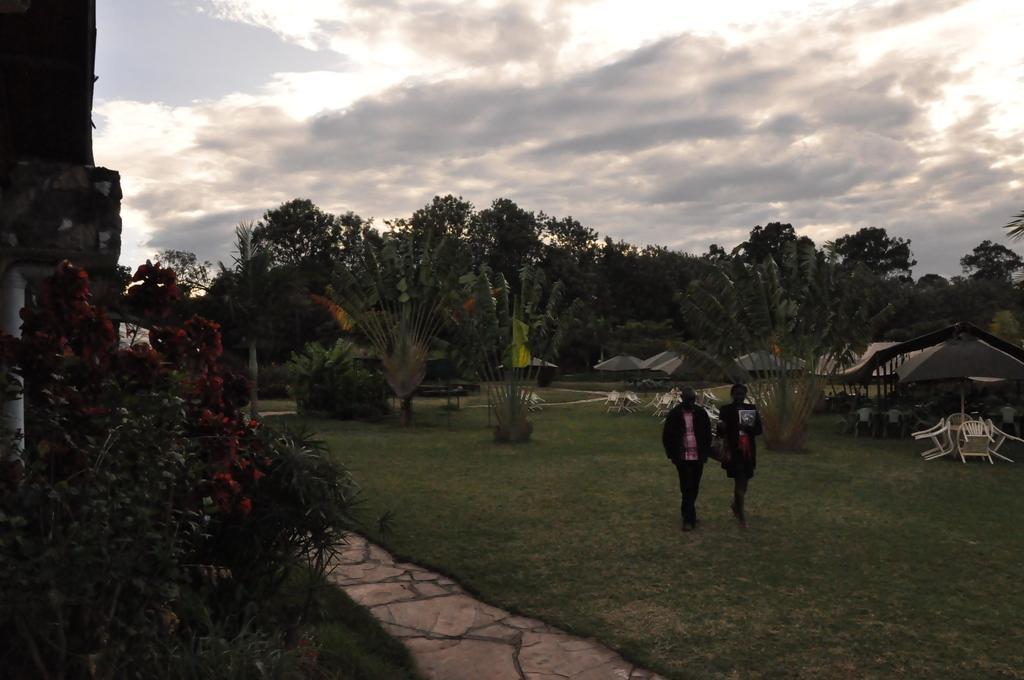Describe this image in one or two sentences. On the left there are trees, flowers and buildings. In the center of the picture there are two persons walking and there is grass. In the background there are umbrellas, tents, chairs, tables, people, plants and trees. Sky is cloudy. 